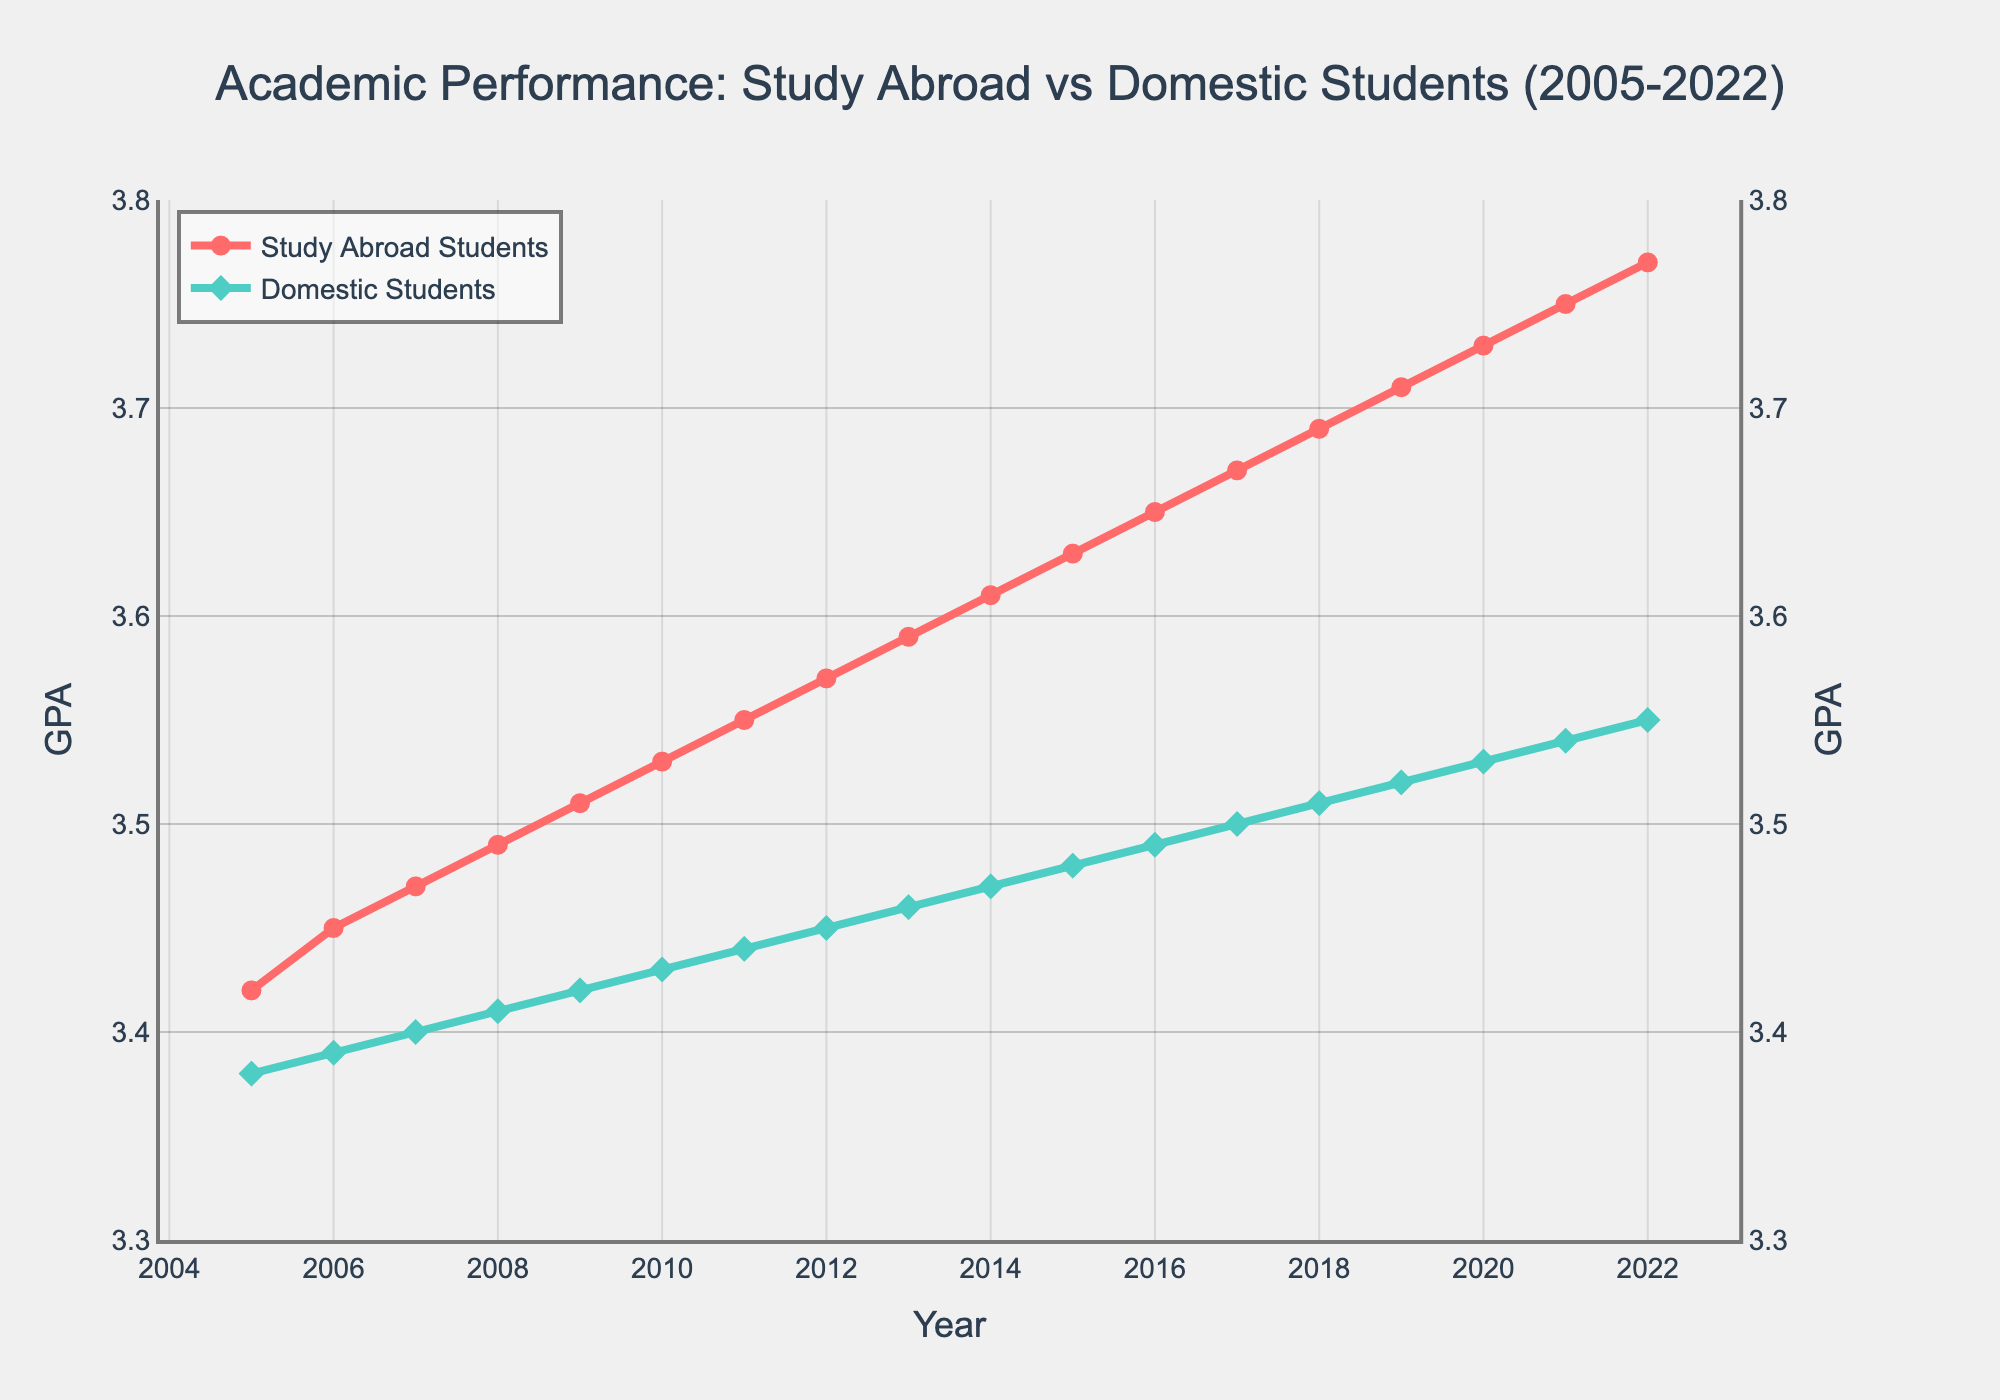what's the highest GPA achieved by study abroad students? The highest value in the "Study Abroad Students GPA" line is observed in 2022 with a GPA of 3.77.
Answer: 3.77 what's the difference in GPA between study abroad students and domestic students in 2022? Subtract the "Domestic Students GPA" from the "Study Abroad Students GPA" for 2022. The difference is 3.77 - 3.55 = 0.22.
Answer: 0.22 how do the GPA trends of study abroad students compare to those of domestic students over the years? Both groups show an upward trend in GPA from 2005 to 2022. However, study abroad students consistently have higher GPAs throughout the period.
Answer: upward for both, higher for study abroad in which year did domestic students achieve a GPA of 3.5 for the first time? Look for the year in the "Domestic Students GPA" series where it first reaches 3.5, which is in 2017.
Answer: 2017 what is the average GPA of domestic students from 2010 to 2020? Add the GPAs from 2010 to 2020 (3.43, 3.44, 3.45, 3.46, 3.47, 3.48, 3.49, 3.50, 3.51, 3.52, 3.53) and divide by the number of years (11). The sum is 38.78. The average is 38.78 / 11 = 3.53.
Answer: 3.53 which year has the smallest difference in GPA between study abroad students and domestic students? Calculate the differences for each year and identify the smallest one. For example, in 2005, the difference is 3.42 - 3.38 = 0.04; repeat for each year. 2005 has the smallest difference of 0.04.
Answer: 2005 what's the GPA trend of study abroad students between 2015 and 2020? Identify the GPAs in those years: 2015 is 3.63, 2016 is 3.65, 2017 is 3.67, 2018 is 3.69, 2019 is 3.71, and 2020 is 3.73. Each year shows an increase, so the trend is upwards.
Answer: upward are study abroad students' GPAs consistently higher than domestic students' GPAs every year? Check each year to see if the study abroad students' GPA is higher than the domestic students' GPA. For all years from 2005 to 2022, this condition holds true.
Answer: yes in which year did the GPA of study abroad students first exceed 3.5? Check the "Study Abroad Students GPA" values year by year starting from 2005 and identify when it first exceeds 3.5, which is in 2009.
Answer: 2009 